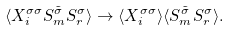Convert formula to latex. <formula><loc_0><loc_0><loc_500><loc_500>\langle X _ { i } ^ { \sigma \sigma } S _ { m } ^ { \tilde { \sigma } } S _ { r } ^ { \sigma } \rangle \rightarrow \langle X _ { i } ^ { \sigma \sigma } \rangle \langle S _ { m } ^ { \tilde { \sigma } } S _ { r } ^ { \sigma } \rangle .</formula> 